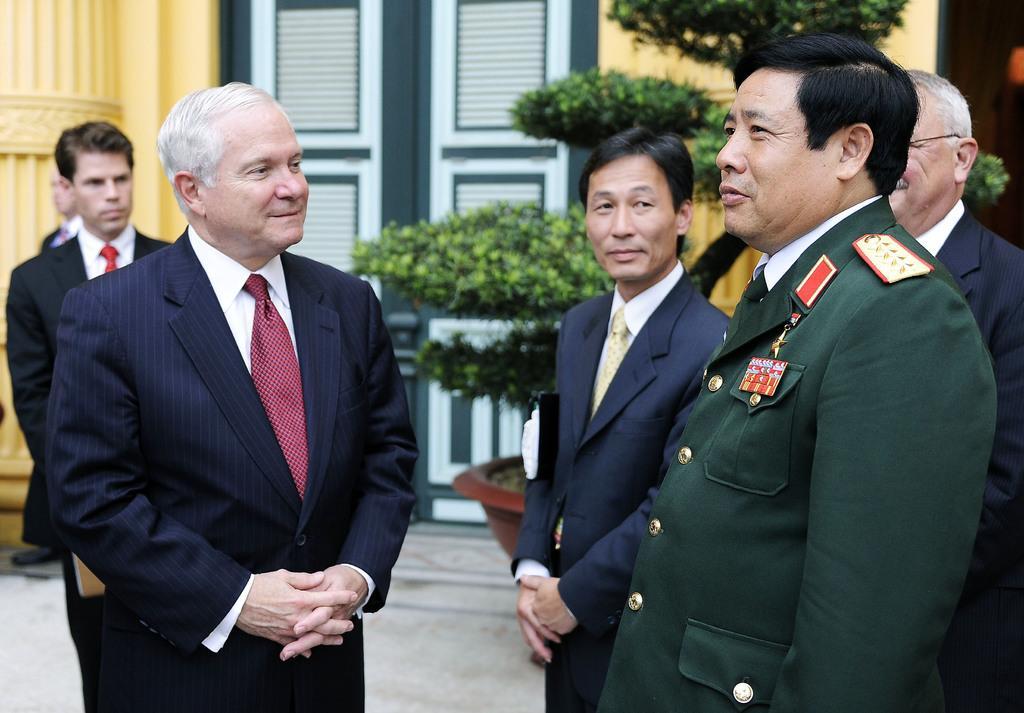Can you describe this image briefly? The man on the right corner of the picture is in uniform which is green in color. Beside him, we see people wearing black and blue blazer. Behind them, we see a flower pot and beside that, we see a door in green color and in the background, we see a wall and a pillar in yellow color. 